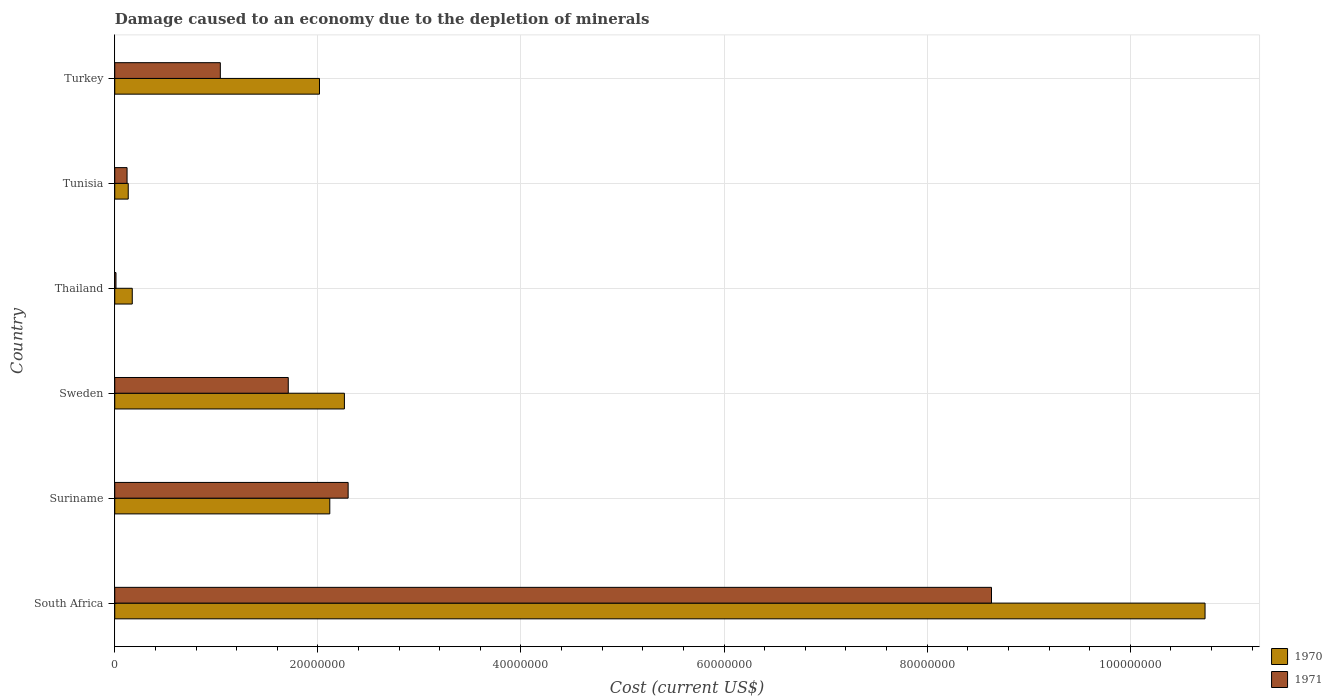What is the label of the 3rd group of bars from the top?
Offer a terse response. Thailand. In how many cases, is the number of bars for a given country not equal to the number of legend labels?
Your response must be concise. 0. What is the cost of damage caused due to the depletion of minerals in 1971 in Suriname?
Ensure brevity in your answer.  2.30e+07. Across all countries, what is the maximum cost of damage caused due to the depletion of minerals in 1970?
Your answer should be compact. 1.07e+08. Across all countries, what is the minimum cost of damage caused due to the depletion of minerals in 1970?
Provide a short and direct response. 1.33e+06. In which country was the cost of damage caused due to the depletion of minerals in 1971 maximum?
Provide a succinct answer. South Africa. In which country was the cost of damage caused due to the depletion of minerals in 1970 minimum?
Your answer should be compact. Tunisia. What is the total cost of damage caused due to the depletion of minerals in 1970 in the graph?
Offer a terse response. 1.74e+08. What is the difference between the cost of damage caused due to the depletion of minerals in 1970 in Suriname and that in Thailand?
Provide a short and direct response. 1.94e+07. What is the difference between the cost of damage caused due to the depletion of minerals in 1971 in Suriname and the cost of damage caused due to the depletion of minerals in 1970 in Tunisia?
Ensure brevity in your answer.  2.17e+07. What is the average cost of damage caused due to the depletion of minerals in 1970 per country?
Give a very brief answer. 2.91e+07. What is the difference between the cost of damage caused due to the depletion of minerals in 1971 and cost of damage caused due to the depletion of minerals in 1970 in Turkey?
Offer a terse response. -9.76e+06. In how many countries, is the cost of damage caused due to the depletion of minerals in 1970 greater than 28000000 US$?
Offer a terse response. 1. What is the ratio of the cost of damage caused due to the depletion of minerals in 1971 in South Africa to that in Suriname?
Your answer should be compact. 3.76. Is the cost of damage caused due to the depletion of minerals in 1970 in Tunisia less than that in Turkey?
Your answer should be compact. Yes. Is the difference between the cost of damage caused due to the depletion of minerals in 1971 in Thailand and Tunisia greater than the difference between the cost of damage caused due to the depletion of minerals in 1970 in Thailand and Tunisia?
Give a very brief answer. No. What is the difference between the highest and the second highest cost of damage caused due to the depletion of minerals in 1971?
Provide a succinct answer. 6.33e+07. What is the difference between the highest and the lowest cost of damage caused due to the depletion of minerals in 1970?
Offer a terse response. 1.06e+08. In how many countries, is the cost of damage caused due to the depletion of minerals in 1970 greater than the average cost of damage caused due to the depletion of minerals in 1970 taken over all countries?
Give a very brief answer. 1. Are all the bars in the graph horizontal?
Provide a short and direct response. Yes. Does the graph contain grids?
Provide a succinct answer. Yes. Where does the legend appear in the graph?
Offer a terse response. Bottom right. How many legend labels are there?
Your response must be concise. 2. How are the legend labels stacked?
Your answer should be very brief. Vertical. What is the title of the graph?
Your response must be concise. Damage caused to an economy due to the depletion of minerals. What is the label or title of the X-axis?
Your answer should be compact. Cost (current US$). What is the label or title of the Y-axis?
Provide a succinct answer. Country. What is the Cost (current US$) in 1970 in South Africa?
Make the answer very short. 1.07e+08. What is the Cost (current US$) in 1971 in South Africa?
Give a very brief answer. 8.63e+07. What is the Cost (current US$) in 1970 in Suriname?
Your response must be concise. 2.12e+07. What is the Cost (current US$) of 1971 in Suriname?
Provide a short and direct response. 2.30e+07. What is the Cost (current US$) in 1970 in Sweden?
Give a very brief answer. 2.26e+07. What is the Cost (current US$) in 1971 in Sweden?
Offer a terse response. 1.71e+07. What is the Cost (current US$) in 1970 in Thailand?
Make the answer very short. 1.72e+06. What is the Cost (current US$) in 1971 in Thailand?
Ensure brevity in your answer.  1.21e+05. What is the Cost (current US$) of 1970 in Tunisia?
Offer a very short reply. 1.33e+06. What is the Cost (current US$) in 1971 in Tunisia?
Your answer should be very brief. 1.21e+06. What is the Cost (current US$) in 1970 in Turkey?
Your answer should be compact. 2.02e+07. What is the Cost (current US$) in 1971 in Turkey?
Offer a terse response. 1.04e+07. Across all countries, what is the maximum Cost (current US$) in 1970?
Your answer should be compact. 1.07e+08. Across all countries, what is the maximum Cost (current US$) of 1971?
Make the answer very short. 8.63e+07. Across all countries, what is the minimum Cost (current US$) in 1970?
Provide a short and direct response. 1.33e+06. Across all countries, what is the minimum Cost (current US$) in 1971?
Your answer should be compact. 1.21e+05. What is the total Cost (current US$) in 1970 in the graph?
Provide a short and direct response. 1.74e+08. What is the total Cost (current US$) in 1971 in the graph?
Your answer should be compact. 1.38e+08. What is the difference between the Cost (current US$) in 1970 in South Africa and that in Suriname?
Provide a short and direct response. 8.62e+07. What is the difference between the Cost (current US$) in 1971 in South Africa and that in Suriname?
Your response must be concise. 6.33e+07. What is the difference between the Cost (current US$) of 1970 in South Africa and that in Sweden?
Keep it short and to the point. 8.47e+07. What is the difference between the Cost (current US$) in 1971 in South Africa and that in Sweden?
Give a very brief answer. 6.92e+07. What is the difference between the Cost (current US$) of 1970 in South Africa and that in Thailand?
Offer a very short reply. 1.06e+08. What is the difference between the Cost (current US$) of 1971 in South Africa and that in Thailand?
Provide a succinct answer. 8.62e+07. What is the difference between the Cost (current US$) of 1970 in South Africa and that in Tunisia?
Provide a succinct answer. 1.06e+08. What is the difference between the Cost (current US$) in 1971 in South Africa and that in Tunisia?
Make the answer very short. 8.51e+07. What is the difference between the Cost (current US$) of 1970 in South Africa and that in Turkey?
Keep it short and to the point. 8.72e+07. What is the difference between the Cost (current US$) in 1971 in South Africa and that in Turkey?
Your answer should be very brief. 7.59e+07. What is the difference between the Cost (current US$) of 1970 in Suriname and that in Sweden?
Make the answer very short. -1.44e+06. What is the difference between the Cost (current US$) of 1971 in Suriname and that in Sweden?
Offer a very short reply. 5.90e+06. What is the difference between the Cost (current US$) of 1970 in Suriname and that in Thailand?
Offer a very short reply. 1.94e+07. What is the difference between the Cost (current US$) of 1971 in Suriname and that in Thailand?
Provide a short and direct response. 2.29e+07. What is the difference between the Cost (current US$) of 1970 in Suriname and that in Tunisia?
Your answer should be compact. 1.98e+07. What is the difference between the Cost (current US$) of 1971 in Suriname and that in Tunisia?
Make the answer very short. 2.18e+07. What is the difference between the Cost (current US$) in 1970 in Suriname and that in Turkey?
Your answer should be very brief. 1.02e+06. What is the difference between the Cost (current US$) of 1971 in Suriname and that in Turkey?
Provide a succinct answer. 1.26e+07. What is the difference between the Cost (current US$) of 1970 in Sweden and that in Thailand?
Provide a short and direct response. 2.09e+07. What is the difference between the Cost (current US$) of 1971 in Sweden and that in Thailand?
Offer a very short reply. 1.70e+07. What is the difference between the Cost (current US$) in 1970 in Sweden and that in Tunisia?
Offer a terse response. 2.13e+07. What is the difference between the Cost (current US$) of 1971 in Sweden and that in Tunisia?
Your answer should be very brief. 1.59e+07. What is the difference between the Cost (current US$) in 1970 in Sweden and that in Turkey?
Your answer should be compact. 2.46e+06. What is the difference between the Cost (current US$) of 1971 in Sweden and that in Turkey?
Your response must be concise. 6.69e+06. What is the difference between the Cost (current US$) of 1970 in Thailand and that in Tunisia?
Your answer should be very brief. 3.98e+05. What is the difference between the Cost (current US$) in 1971 in Thailand and that in Tunisia?
Provide a succinct answer. -1.09e+06. What is the difference between the Cost (current US$) of 1970 in Thailand and that in Turkey?
Your answer should be very brief. -1.84e+07. What is the difference between the Cost (current US$) of 1971 in Thailand and that in Turkey?
Give a very brief answer. -1.03e+07. What is the difference between the Cost (current US$) in 1970 in Tunisia and that in Turkey?
Provide a succinct answer. -1.88e+07. What is the difference between the Cost (current US$) of 1971 in Tunisia and that in Turkey?
Ensure brevity in your answer.  -9.18e+06. What is the difference between the Cost (current US$) in 1970 in South Africa and the Cost (current US$) in 1971 in Suriname?
Your response must be concise. 8.44e+07. What is the difference between the Cost (current US$) in 1970 in South Africa and the Cost (current US$) in 1971 in Sweden?
Make the answer very short. 9.03e+07. What is the difference between the Cost (current US$) of 1970 in South Africa and the Cost (current US$) of 1971 in Thailand?
Offer a very short reply. 1.07e+08. What is the difference between the Cost (current US$) of 1970 in South Africa and the Cost (current US$) of 1971 in Tunisia?
Provide a short and direct response. 1.06e+08. What is the difference between the Cost (current US$) in 1970 in South Africa and the Cost (current US$) in 1971 in Turkey?
Your answer should be very brief. 9.70e+07. What is the difference between the Cost (current US$) in 1970 in Suriname and the Cost (current US$) in 1971 in Sweden?
Give a very brief answer. 4.09e+06. What is the difference between the Cost (current US$) of 1970 in Suriname and the Cost (current US$) of 1971 in Thailand?
Keep it short and to the point. 2.11e+07. What is the difference between the Cost (current US$) in 1970 in Suriname and the Cost (current US$) in 1971 in Tunisia?
Offer a terse response. 2.00e+07. What is the difference between the Cost (current US$) in 1970 in Suriname and the Cost (current US$) in 1971 in Turkey?
Provide a short and direct response. 1.08e+07. What is the difference between the Cost (current US$) in 1970 in Sweden and the Cost (current US$) in 1971 in Thailand?
Provide a short and direct response. 2.25e+07. What is the difference between the Cost (current US$) of 1970 in Sweden and the Cost (current US$) of 1971 in Tunisia?
Provide a succinct answer. 2.14e+07. What is the difference between the Cost (current US$) in 1970 in Sweden and the Cost (current US$) in 1971 in Turkey?
Keep it short and to the point. 1.22e+07. What is the difference between the Cost (current US$) in 1970 in Thailand and the Cost (current US$) in 1971 in Tunisia?
Make the answer very short. 5.13e+05. What is the difference between the Cost (current US$) of 1970 in Thailand and the Cost (current US$) of 1971 in Turkey?
Provide a succinct answer. -8.67e+06. What is the difference between the Cost (current US$) of 1970 in Tunisia and the Cost (current US$) of 1971 in Turkey?
Provide a succinct answer. -9.07e+06. What is the average Cost (current US$) in 1970 per country?
Your answer should be compact. 2.91e+07. What is the average Cost (current US$) of 1971 per country?
Offer a terse response. 2.30e+07. What is the difference between the Cost (current US$) of 1970 and Cost (current US$) of 1971 in South Africa?
Offer a very short reply. 2.10e+07. What is the difference between the Cost (current US$) in 1970 and Cost (current US$) in 1971 in Suriname?
Your response must be concise. -1.81e+06. What is the difference between the Cost (current US$) in 1970 and Cost (current US$) in 1971 in Sweden?
Provide a short and direct response. 5.53e+06. What is the difference between the Cost (current US$) of 1970 and Cost (current US$) of 1971 in Thailand?
Keep it short and to the point. 1.60e+06. What is the difference between the Cost (current US$) of 1970 and Cost (current US$) of 1971 in Tunisia?
Offer a very short reply. 1.16e+05. What is the difference between the Cost (current US$) in 1970 and Cost (current US$) in 1971 in Turkey?
Offer a very short reply. 9.76e+06. What is the ratio of the Cost (current US$) of 1970 in South Africa to that in Suriname?
Give a very brief answer. 5.07. What is the ratio of the Cost (current US$) of 1971 in South Africa to that in Suriname?
Keep it short and to the point. 3.76. What is the ratio of the Cost (current US$) in 1970 in South Africa to that in Sweden?
Provide a short and direct response. 4.75. What is the ratio of the Cost (current US$) in 1971 in South Africa to that in Sweden?
Ensure brevity in your answer.  5.05. What is the ratio of the Cost (current US$) of 1970 in South Africa to that in Thailand?
Provide a short and direct response. 62.25. What is the ratio of the Cost (current US$) of 1971 in South Africa to that in Thailand?
Give a very brief answer. 716.15. What is the ratio of the Cost (current US$) of 1970 in South Africa to that in Tunisia?
Provide a short and direct response. 80.9. What is the ratio of the Cost (current US$) in 1971 in South Africa to that in Tunisia?
Ensure brevity in your answer.  71.26. What is the ratio of the Cost (current US$) of 1970 in South Africa to that in Turkey?
Ensure brevity in your answer.  5.33. What is the ratio of the Cost (current US$) of 1971 in South Africa to that in Turkey?
Make the answer very short. 8.3. What is the ratio of the Cost (current US$) in 1970 in Suriname to that in Sweden?
Provide a short and direct response. 0.94. What is the ratio of the Cost (current US$) of 1971 in Suriname to that in Sweden?
Your answer should be compact. 1.35. What is the ratio of the Cost (current US$) of 1970 in Suriname to that in Thailand?
Your response must be concise. 12.28. What is the ratio of the Cost (current US$) in 1971 in Suriname to that in Thailand?
Provide a succinct answer. 190.64. What is the ratio of the Cost (current US$) of 1970 in Suriname to that in Tunisia?
Keep it short and to the point. 15.96. What is the ratio of the Cost (current US$) in 1971 in Suriname to that in Tunisia?
Ensure brevity in your answer.  18.97. What is the ratio of the Cost (current US$) of 1970 in Suriname to that in Turkey?
Offer a terse response. 1.05. What is the ratio of the Cost (current US$) of 1971 in Suriname to that in Turkey?
Provide a succinct answer. 2.21. What is the ratio of the Cost (current US$) in 1970 in Sweden to that in Thailand?
Provide a short and direct response. 13.11. What is the ratio of the Cost (current US$) in 1971 in Sweden to that in Thailand?
Keep it short and to the point. 141.73. What is the ratio of the Cost (current US$) of 1970 in Sweden to that in Tunisia?
Offer a terse response. 17.04. What is the ratio of the Cost (current US$) in 1971 in Sweden to that in Tunisia?
Your answer should be compact. 14.1. What is the ratio of the Cost (current US$) in 1970 in Sweden to that in Turkey?
Offer a very short reply. 1.12. What is the ratio of the Cost (current US$) of 1971 in Sweden to that in Turkey?
Give a very brief answer. 1.64. What is the ratio of the Cost (current US$) in 1970 in Thailand to that in Tunisia?
Provide a succinct answer. 1.3. What is the ratio of the Cost (current US$) of 1971 in Thailand to that in Tunisia?
Keep it short and to the point. 0.1. What is the ratio of the Cost (current US$) of 1970 in Thailand to that in Turkey?
Give a very brief answer. 0.09. What is the ratio of the Cost (current US$) of 1971 in Thailand to that in Turkey?
Offer a very short reply. 0.01. What is the ratio of the Cost (current US$) in 1970 in Tunisia to that in Turkey?
Provide a succinct answer. 0.07. What is the ratio of the Cost (current US$) in 1971 in Tunisia to that in Turkey?
Ensure brevity in your answer.  0.12. What is the difference between the highest and the second highest Cost (current US$) of 1970?
Offer a very short reply. 8.47e+07. What is the difference between the highest and the second highest Cost (current US$) in 1971?
Ensure brevity in your answer.  6.33e+07. What is the difference between the highest and the lowest Cost (current US$) in 1970?
Keep it short and to the point. 1.06e+08. What is the difference between the highest and the lowest Cost (current US$) in 1971?
Keep it short and to the point. 8.62e+07. 